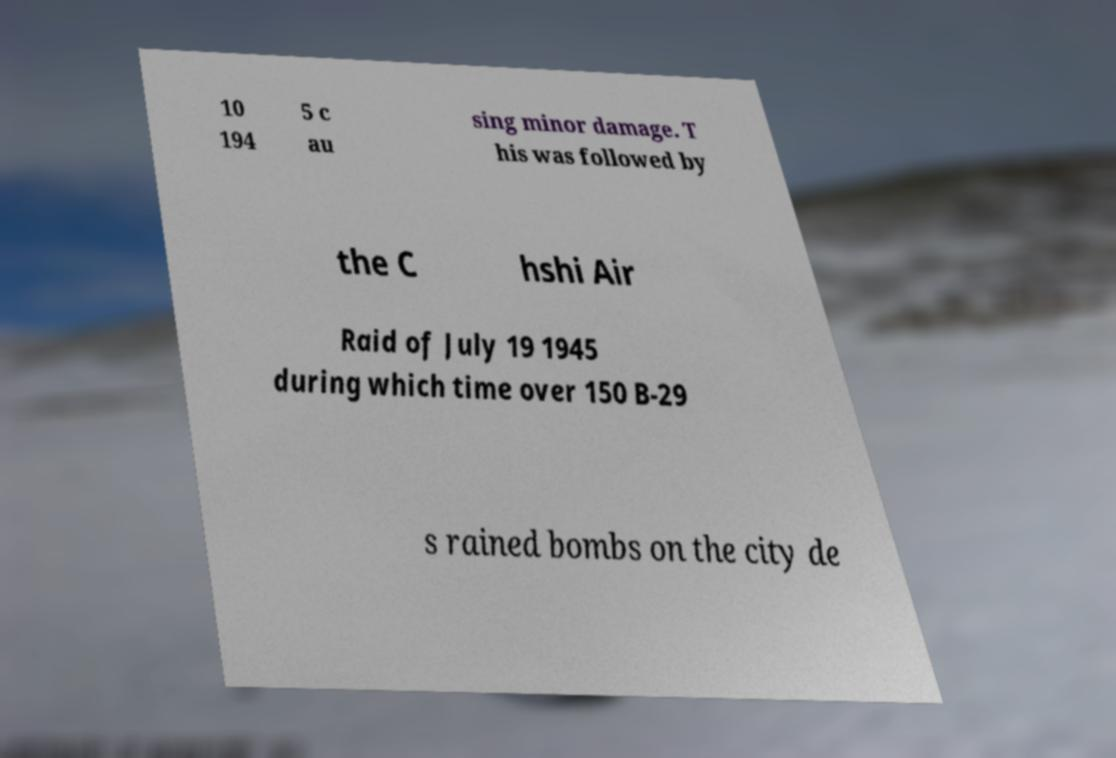Can you read and provide the text displayed in the image?This photo seems to have some interesting text. Can you extract and type it out for me? 10 194 5 c au sing minor damage. T his was followed by the C hshi Air Raid of July 19 1945 during which time over 150 B-29 s rained bombs on the city de 